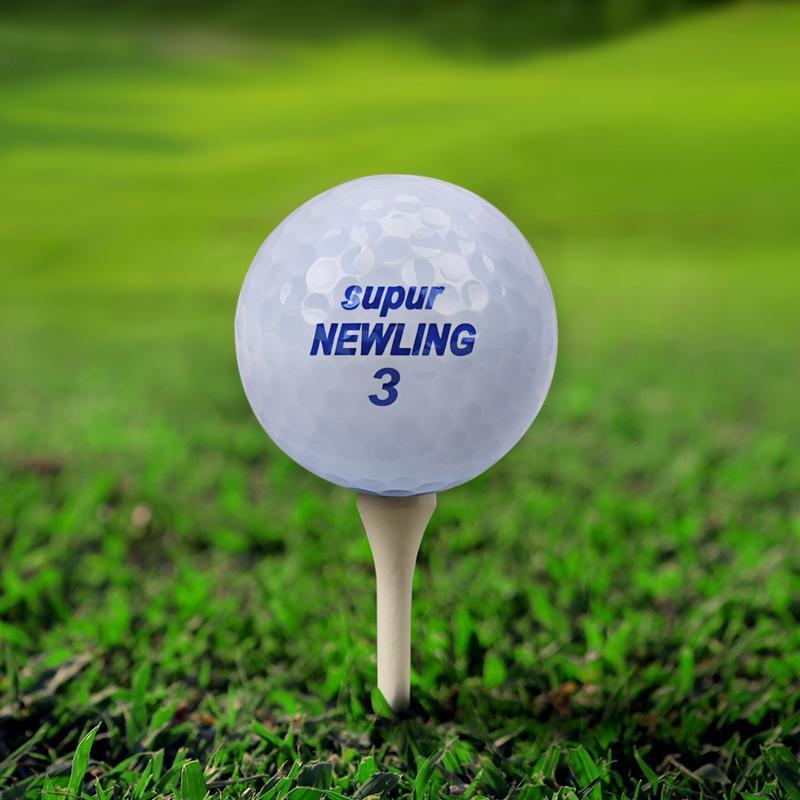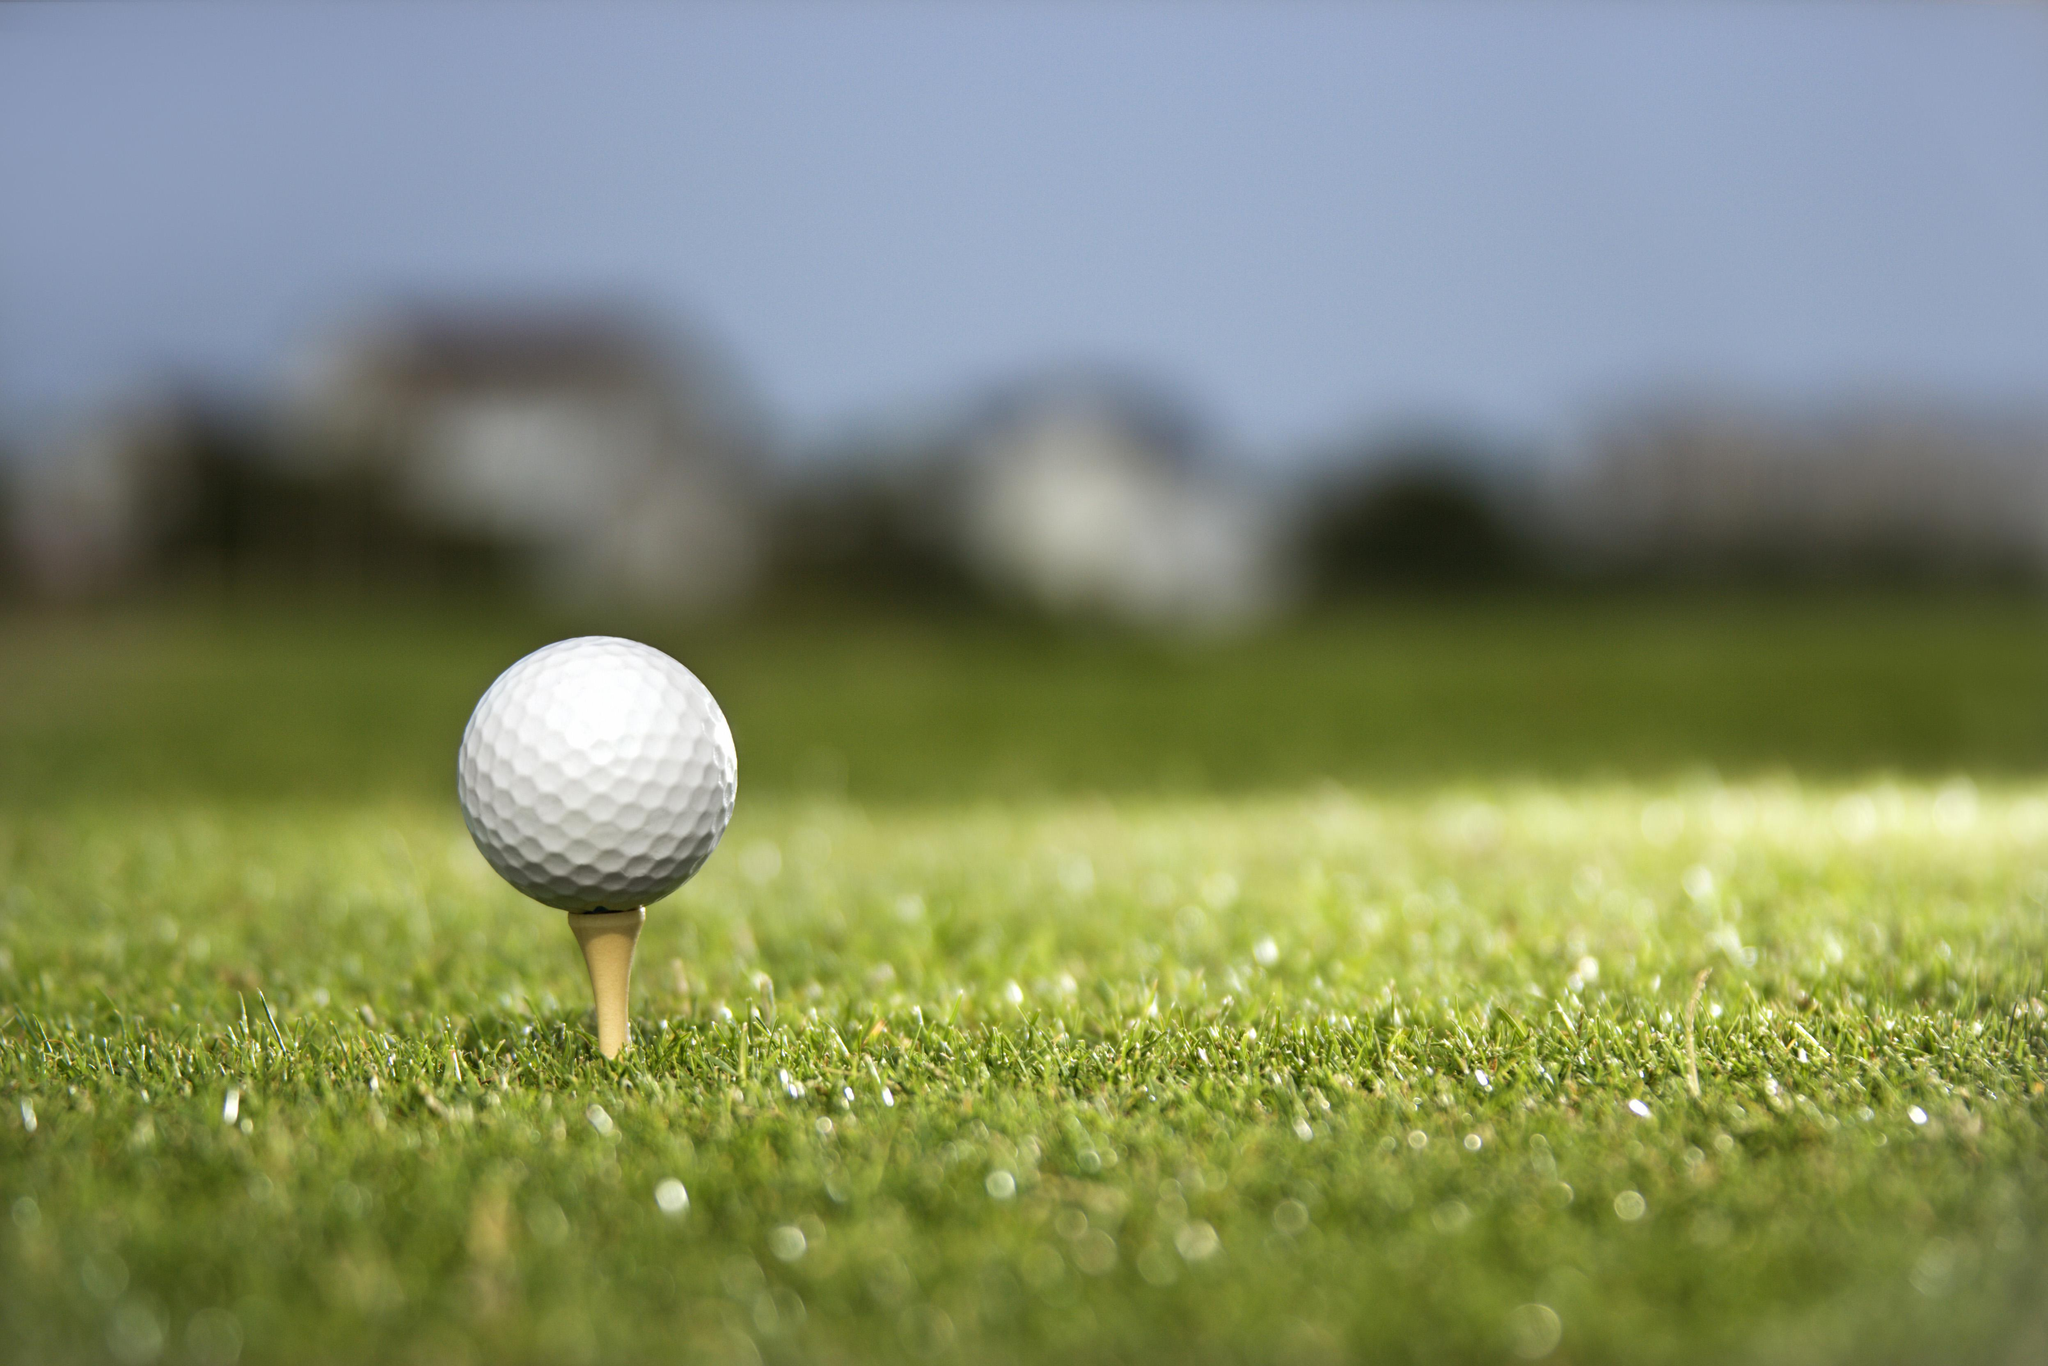The first image is the image on the left, the second image is the image on the right. Examine the images to the left and right. Is the description "A golf club is behind at least one golf ball." accurate? Answer yes or no. No. The first image is the image on the left, the second image is the image on the right. Evaluate the accuracy of this statement regarding the images: "At least one image shows a golf ball on top of a tee.". Is it true? Answer yes or no. Yes. 